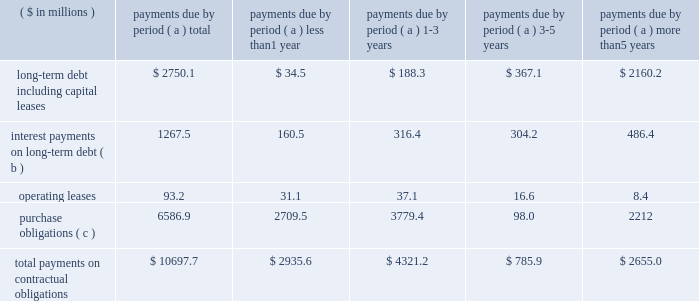Page 27 of 100 other liquidity items cash payments required for long-term debt maturities , rental payments under noncancellable operating leases , purchase obligations and other commitments in effect at december 31 , 2010 , are summarized in the table: .
Total payments on contractual obligations $ 10697.7 $ 2935.6 $ 4321.2 $ 785.9 $ 2655.0 ( a ) amounts reported in local currencies have been translated at the year-end 2010 exchange rates .
( b ) for variable rate facilities , amounts are based on interest rates in effect at year end and do not contemplate the effects of hedging instruments .
( c ) the company 2019s purchase obligations include contracted amounts for aluminum , steel and other direct materials .
Also included are commitments for purchases of natural gas and electricity , aerospace and technologies contracts and other less significant items .
In cases where variable prices and/or usage are involved , management 2019s best estimates have been used .
Depending on the circumstances , early termination of the contracts may or may not result in penalties and , therefore , actual payments could vary significantly .
The table above does not include $ 60.1 million of uncertain tax positions , the timing of which is uncertain .
Contributions to the company 2019s defined benefit pension plans , not including the unfunded german plans , are expected to be in the range of $ 30 million in 2011 .
This estimate may change based on changes in the pension protection act and actual plan asset performance , among other factors .
Benefit payments related to these plans are expected to be $ 71.4 million , $ 74.0 million , $ 77.1 million , $ 80.3 million and $ 84.9 million for the years ending december 31 , 2011 through 2015 , respectively , and a total of $ 483.1 million for the years 2016 through 2020 .
Payments to participants in the unfunded german plans are expected to be between $ 21.8 million ( 20ac16.5 million ) to $ 23.2 million ( 20ac17.5 million ) in each of the years 2011 through 2015 and a total of $ 102.7 million ( 20ac77.5 million ) for the years 2016 through 2020 .
For the u.s .
Pension plans in 2011 , we changed our return on asset assumption to 8.00 percent ( from 8.25 percent in 2010 ) and our discount rate assumption to an average of 5.55 percent ( from 6.00 percent in 2010 ) .
Based on the changes in assumptions , pension expense in 2011 is anticipated to be relatively flat compared to 2010 .
A reduction of the expected return on pension assets assumption by a quarter of a percentage point would result in an estimated $ 2.9 million increase in the 2011 global pension expense , while a quarter of a percentage point reduction in the discount rate applied to the pension liability would result in an estimated $ 3.5 million of additional pension expense in 2011 .
Additional information regarding the company 2019s pension plans is provided in note 14 accompanying the consolidated financial statements within item 8 of this report .
Annual cash dividends paid on common stock were 20 cents per share in 2010 , 2009 and 2008 .
Total dividends paid were $ 35.8 million in 2010 , $ 37.4 million in 2009 and $ 37.5 million in 2008 .
On january 26 , 2011 , the company 2019s board of directors approved an increase in the quarterly dividends to 7 cents per share .
Share repurchases our share repurchases , net of issuances , totaled $ 506.7 million in 2010 , $ 5.1 million in 2009 and $ 299.6 million in 2008 .
On november 2 , 2010 , we acquired 2775408 shares of our publicly held common stock in a private transaction for $ 88.8 million .
On february 17 , 2010 , we entered into an accelerated share repurchase agreement to buy $ 125.0 million of our common shares using cash on hand and available borrowings .
We advanced the $ 125.0 million on february 22 , 2010 , and received 4323598 shares , which represented 90 percent of the total shares as calculated using the previous day 2019s closing price .
The agreement was settled on may 20 , 2010 , and the company received an additional 398206 shares .
Net repurchases in 2008 included a $ 31 million settlement on january 7 , 2008 , of a forward contract entered into in december 2007 for the repurchase of 1350000 shares .
From january 1 through february 24 , 2011 , ball repurchased an additional $ 143.3 million of its common stock. .
What would the total payments on contractual obligations be in millions if the uncertain tax positions were considered , and they fell in the next five years? 
Computations: (10697.7 + 60.1)
Answer: 10757.8. Page 27 of 100 other liquidity items cash payments required for long-term debt maturities , rental payments under noncancellable operating leases , purchase obligations and other commitments in effect at december 31 , 2010 , are summarized in the table: .
Total payments on contractual obligations $ 10697.7 $ 2935.6 $ 4321.2 $ 785.9 $ 2655.0 ( a ) amounts reported in local currencies have been translated at the year-end 2010 exchange rates .
( b ) for variable rate facilities , amounts are based on interest rates in effect at year end and do not contemplate the effects of hedging instruments .
( c ) the company 2019s purchase obligations include contracted amounts for aluminum , steel and other direct materials .
Also included are commitments for purchases of natural gas and electricity , aerospace and technologies contracts and other less significant items .
In cases where variable prices and/or usage are involved , management 2019s best estimates have been used .
Depending on the circumstances , early termination of the contracts may or may not result in penalties and , therefore , actual payments could vary significantly .
The table above does not include $ 60.1 million of uncertain tax positions , the timing of which is uncertain .
Contributions to the company 2019s defined benefit pension plans , not including the unfunded german plans , are expected to be in the range of $ 30 million in 2011 .
This estimate may change based on changes in the pension protection act and actual plan asset performance , among other factors .
Benefit payments related to these plans are expected to be $ 71.4 million , $ 74.0 million , $ 77.1 million , $ 80.3 million and $ 84.9 million for the years ending december 31 , 2011 through 2015 , respectively , and a total of $ 483.1 million for the years 2016 through 2020 .
Payments to participants in the unfunded german plans are expected to be between $ 21.8 million ( 20ac16.5 million ) to $ 23.2 million ( 20ac17.5 million ) in each of the years 2011 through 2015 and a total of $ 102.7 million ( 20ac77.5 million ) for the years 2016 through 2020 .
For the u.s .
Pension plans in 2011 , we changed our return on asset assumption to 8.00 percent ( from 8.25 percent in 2010 ) and our discount rate assumption to an average of 5.55 percent ( from 6.00 percent in 2010 ) .
Based on the changes in assumptions , pension expense in 2011 is anticipated to be relatively flat compared to 2010 .
A reduction of the expected return on pension assets assumption by a quarter of a percentage point would result in an estimated $ 2.9 million increase in the 2011 global pension expense , while a quarter of a percentage point reduction in the discount rate applied to the pension liability would result in an estimated $ 3.5 million of additional pension expense in 2011 .
Additional information regarding the company 2019s pension plans is provided in note 14 accompanying the consolidated financial statements within item 8 of this report .
Annual cash dividends paid on common stock were 20 cents per share in 2010 , 2009 and 2008 .
Total dividends paid were $ 35.8 million in 2010 , $ 37.4 million in 2009 and $ 37.5 million in 2008 .
On january 26 , 2011 , the company 2019s board of directors approved an increase in the quarterly dividends to 7 cents per share .
Share repurchases our share repurchases , net of issuances , totaled $ 506.7 million in 2010 , $ 5.1 million in 2009 and $ 299.6 million in 2008 .
On november 2 , 2010 , we acquired 2775408 shares of our publicly held common stock in a private transaction for $ 88.8 million .
On february 17 , 2010 , we entered into an accelerated share repurchase agreement to buy $ 125.0 million of our common shares using cash on hand and available borrowings .
We advanced the $ 125.0 million on february 22 , 2010 , and received 4323598 shares , which represented 90 percent of the total shares as calculated using the previous day 2019s closing price .
The agreement was settled on may 20 , 2010 , and the company received an additional 398206 shares .
Net repurchases in 2008 included a $ 31 million settlement on january 7 , 2008 , of a forward contract entered into in december 2007 for the repurchase of 1350000 shares .
From january 1 through february 24 , 2011 , ball repurchased an additional $ 143.3 million of its common stock. .
What percentage of total cash payments required for long-term debt maturities , rental payments under noncancellable operating leases , purchase obligations and other commitments in effect at december 31 , 2010 are comprised of long-term debt including capital leases? 
Computations: (2750.1 / 10697.7)
Answer: 0.25707. Page 27 of 100 other liquidity items cash payments required for long-term debt maturities , rental payments under noncancellable operating leases , purchase obligations and other commitments in effect at december 31 , 2010 , are summarized in the table: .
Total payments on contractual obligations $ 10697.7 $ 2935.6 $ 4321.2 $ 785.9 $ 2655.0 ( a ) amounts reported in local currencies have been translated at the year-end 2010 exchange rates .
( b ) for variable rate facilities , amounts are based on interest rates in effect at year end and do not contemplate the effects of hedging instruments .
( c ) the company 2019s purchase obligations include contracted amounts for aluminum , steel and other direct materials .
Also included are commitments for purchases of natural gas and electricity , aerospace and technologies contracts and other less significant items .
In cases where variable prices and/or usage are involved , management 2019s best estimates have been used .
Depending on the circumstances , early termination of the contracts may or may not result in penalties and , therefore , actual payments could vary significantly .
The table above does not include $ 60.1 million of uncertain tax positions , the timing of which is uncertain .
Contributions to the company 2019s defined benefit pension plans , not including the unfunded german plans , are expected to be in the range of $ 30 million in 2011 .
This estimate may change based on changes in the pension protection act and actual plan asset performance , among other factors .
Benefit payments related to these plans are expected to be $ 71.4 million , $ 74.0 million , $ 77.1 million , $ 80.3 million and $ 84.9 million for the years ending december 31 , 2011 through 2015 , respectively , and a total of $ 483.1 million for the years 2016 through 2020 .
Payments to participants in the unfunded german plans are expected to be between $ 21.8 million ( 20ac16.5 million ) to $ 23.2 million ( 20ac17.5 million ) in each of the years 2011 through 2015 and a total of $ 102.7 million ( 20ac77.5 million ) for the years 2016 through 2020 .
For the u.s .
Pension plans in 2011 , we changed our return on asset assumption to 8.00 percent ( from 8.25 percent in 2010 ) and our discount rate assumption to an average of 5.55 percent ( from 6.00 percent in 2010 ) .
Based on the changes in assumptions , pension expense in 2011 is anticipated to be relatively flat compared to 2010 .
A reduction of the expected return on pension assets assumption by a quarter of a percentage point would result in an estimated $ 2.9 million increase in the 2011 global pension expense , while a quarter of a percentage point reduction in the discount rate applied to the pension liability would result in an estimated $ 3.5 million of additional pension expense in 2011 .
Additional information regarding the company 2019s pension plans is provided in note 14 accompanying the consolidated financial statements within item 8 of this report .
Annual cash dividends paid on common stock were 20 cents per share in 2010 , 2009 and 2008 .
Total dividends paid were $ 35.8 million in 2010 , $ 37.4 million in 2009 and $ 37.5 million in 2008 .
On january 26 , 2011 , the company 2019s board of directors approved an increase in the quarterly dividends to 7 cents per share .
Share repurchases our share repurchases , net of issuances , totaled $ 506.7 million in 2010 , $ 5.1 million in 2009 and $ 299.6 million in 2008 .
On november 2 , 2010 , we acquired 2775408 shares of our publicly held common stock in a private transaction for $ 88.8 million .
On february 17 , 2010 , we entered into an accelerated share repurchase agreement to buy $ 125.0 million of our common shares using cash on hand and available borrowings .
We advanced the $ 125.0 million on february 22 , 2010 , and received 4323598 shares , which represented 90 percent of the total shares as calculated using the previous day 2019s closing price .
The agreement was settled on may 20 , 2010 , and the company received an additional 398206 shares .
Net repurchases in 2008 included a $ 31 million settlement on january 7 , 2008 , of a forward contract entered into in december 2007 for the repurchase of 1350000 shares .
From january 1 through february 24 , 2011 , ball repurchased an additional $ 143.3 million of its common stock. .
What percentage of total cash payments required for long-term debt maturities , rental payments under noncancellable operating leases , purchase obligations and other commitments in effect at december 31 , 2010 are comprised of purchase obligations? 
Computations: (6586.9 / 10697.7)
Answer: 0.61573. 